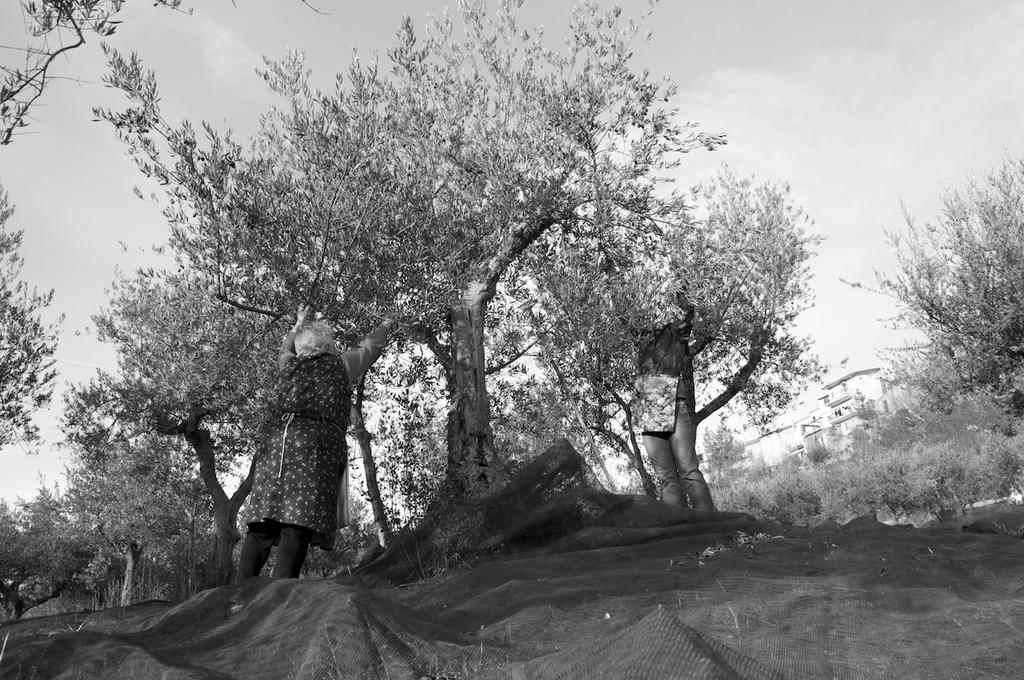What type of natural elements can be seen in the image? There are trees in the image. Can you describe the people in the image? There are people in the image. What is visible in the background of the image? The sky and buildings are visible in the background of the image. What object is present at the bottom of the image? There is a net at the bottom of the image. What grade does the eggnog receive in the image? There is no eggnog present in the image, so it cannot receive a grade. 